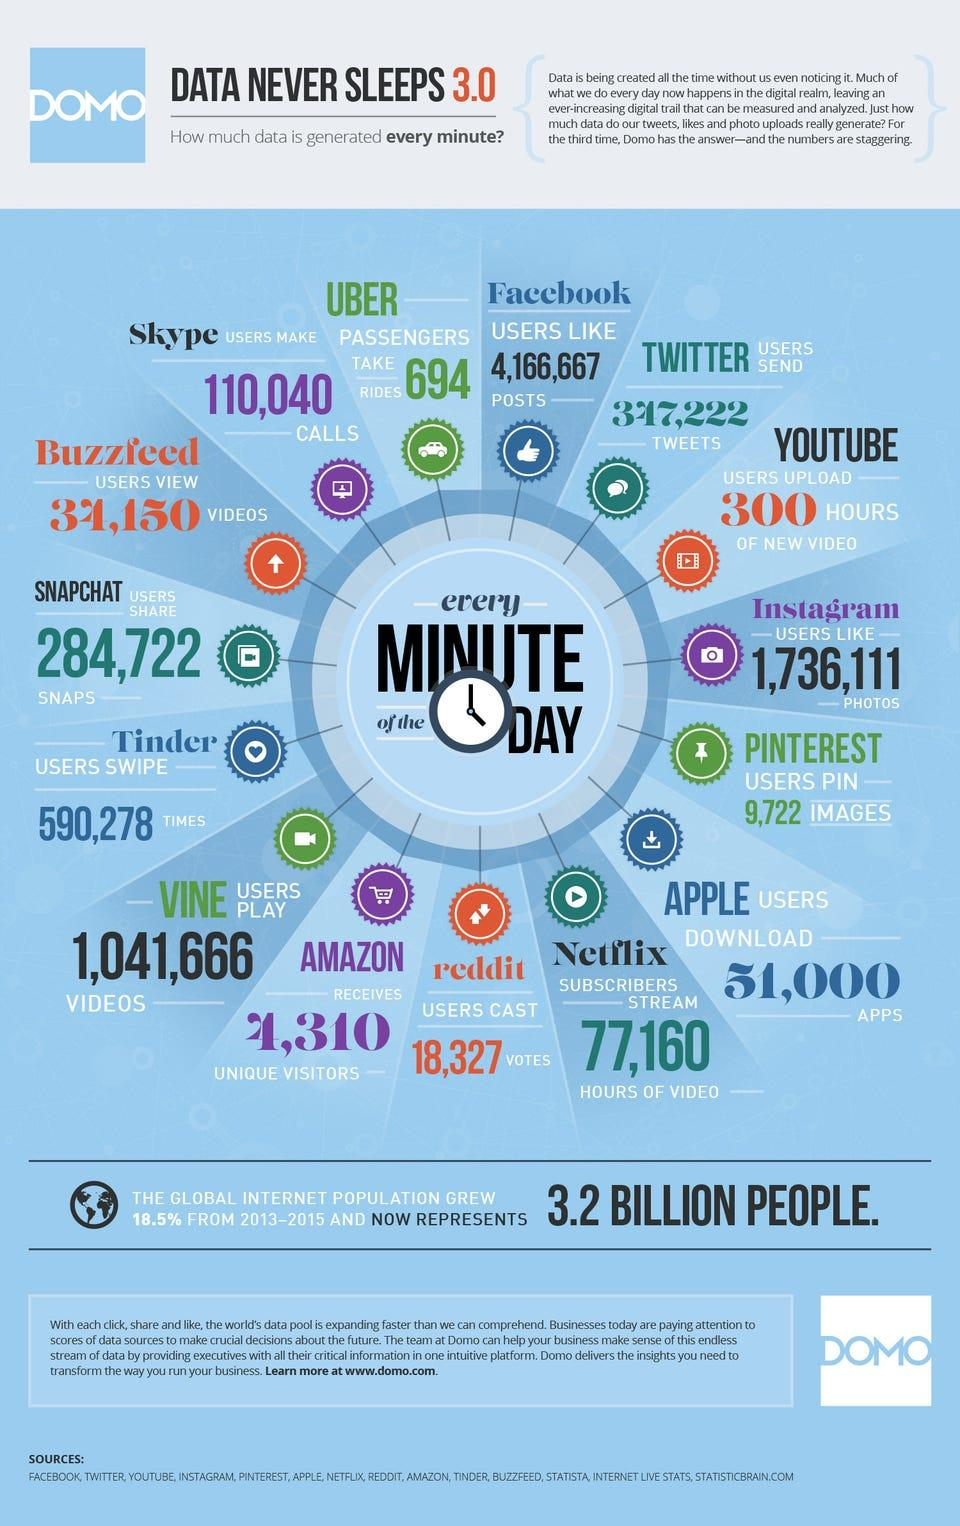Point out several critical features in this image. The total length of the programs watched on Netflix in a minute is approximately 77,160 hours of video. In a minute on YouTube, approximately 300 hours of new video are uploaded. According to recent data, approximately 347,222 tweets are created every minute on Twitter. In a minute, Apple users typically install approximately 51,000 new applications. According to recent data, approximately 4,310 unique users visit the Amazon website in a minute. 